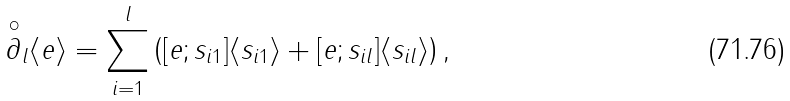Convert formula to latex. <formula><loc_0><loc_0><loc_500><loc_500>\overset { \circ } { \partial } _ { l } \langle e \rangle = \sum _ { i = 1 } ^ { l } \left ( [ e ; s _ { i 1 } ] \langle s _ { i 1 } \rangle + [ e ; s _ { i l } ] \langle s _ { i l } \rangle \right ) ,</formula> 